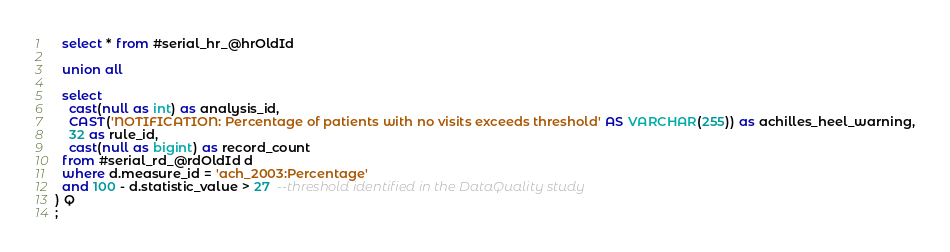Convert code to text. <code><loc_0><loc_0><loc_500><loc_500><_SQL_>  select * from #serial_hr_@hrOldId
  
  union all
  
  select 
    cast(null as int) as analysis_id,
    CAST('NOTIFICATION: Percentage of patients with no visits exceeds threshold' AS VARCHAR(255)) as achilles_heel_warning,
    32 as rule_id,
    cast(null as bigint) as record_count
  from #serial_rd_@rdOldId d
  where d.measure_id = 'ach_2003:Percentage'
  and 100 - d.statistic_value > 27  --threshold identified in the DataQuality study
) Q
;</code> 